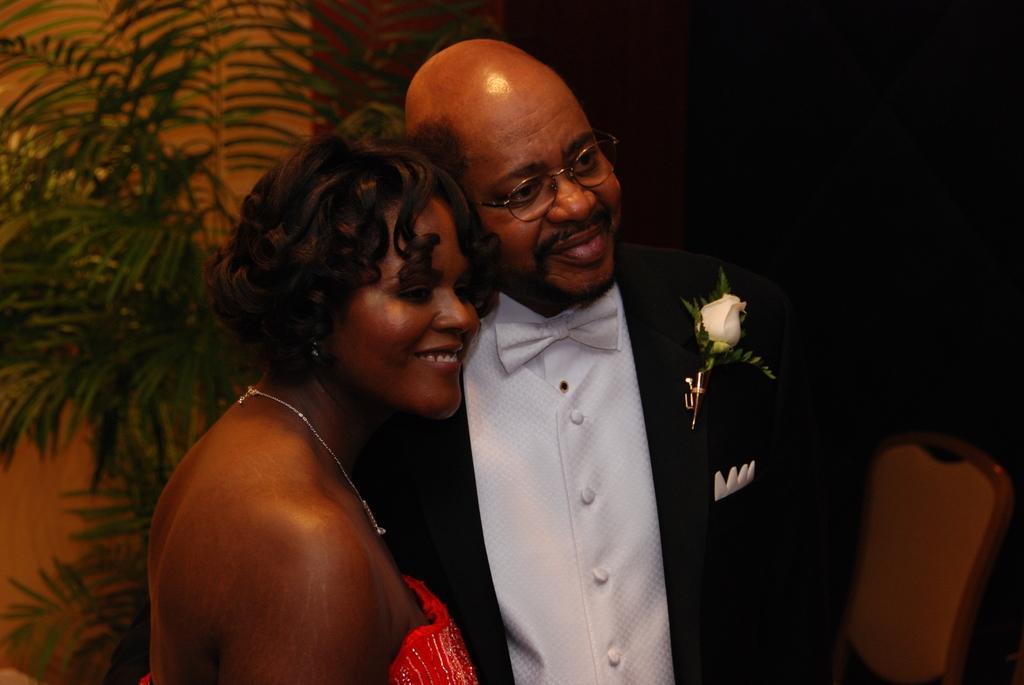Describe this image in one or two sentences. In this image, I can see the man and woman standing and smiling. This looks like a tree. On the right side of the image, I can see a chair. The background looks dark. 